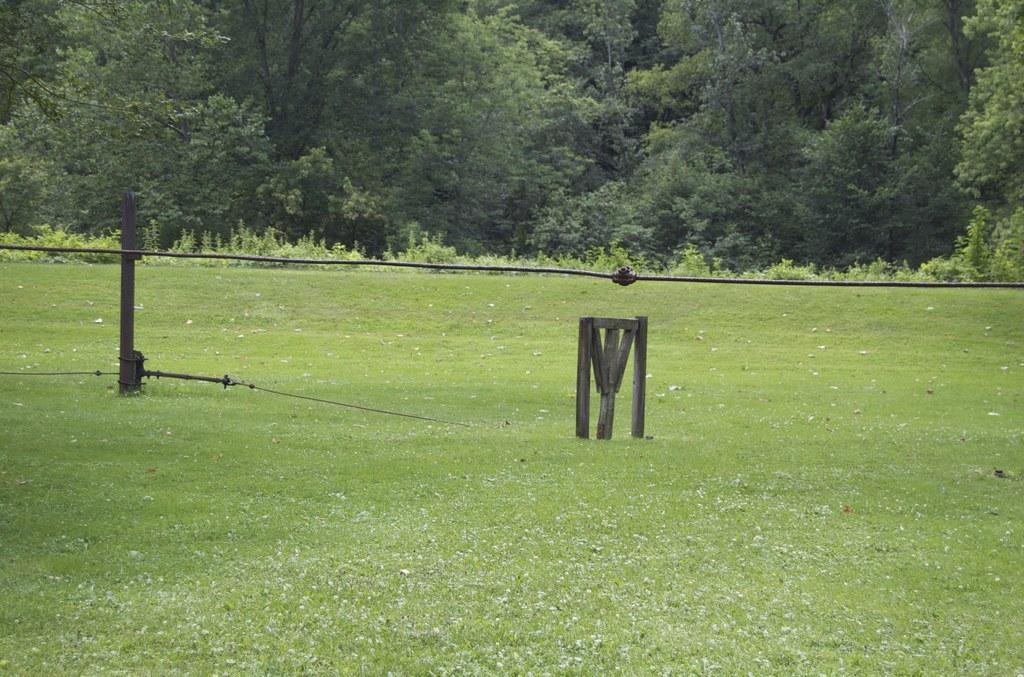What type of vegetation can be seen in the image? There is grass and plants in the image. What material is the wooden object made of? The wooden object in the image is made of wood. What is attached to the pole in the image? There are wires attached to the pole in the image. What can be seen on the trees in the image? The trees in the image have branches and leaves. What type of star can be seen shining in the image? There is no star visible in the image; it features grass, plants, a wooden object, a pole with wires, and trees with branches and leaves. What type of line is present in the image? There is no specific line mentioned in the provided facts; the image features grass, plants, a wooden object, a pole with wires, and trees with branches and leaves. 